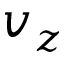<formula> <loc_0><loc_0><loc_500><loc_500>v _ { z }</formula> 